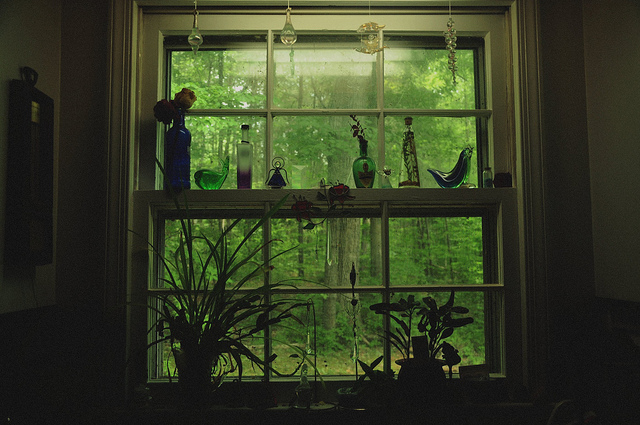Imagine there's a story connected to this window. What might it be? Once, there was a kind old woman named Elara who lived in this cozy house. Every morning, she would awake at dawn to tend to her plants and clean her beloved glass vases. Each vase on the windowsill had a story; one was a gift from her late husband, another a souvenir from her travels, and the bird-shaped vase represented freedom and peace. Elara found solace watching the changing seasons through this very window, as if nature was putting on a private show just for her. Her love for nature was passed down to her grandchildren, who would visit her every summer, filling the house with laughter and the scent of fresh flowers they picked from the garden outside. Every vase and plant in this window holds memories of love, loss, and the beauty of life's simple moments. 